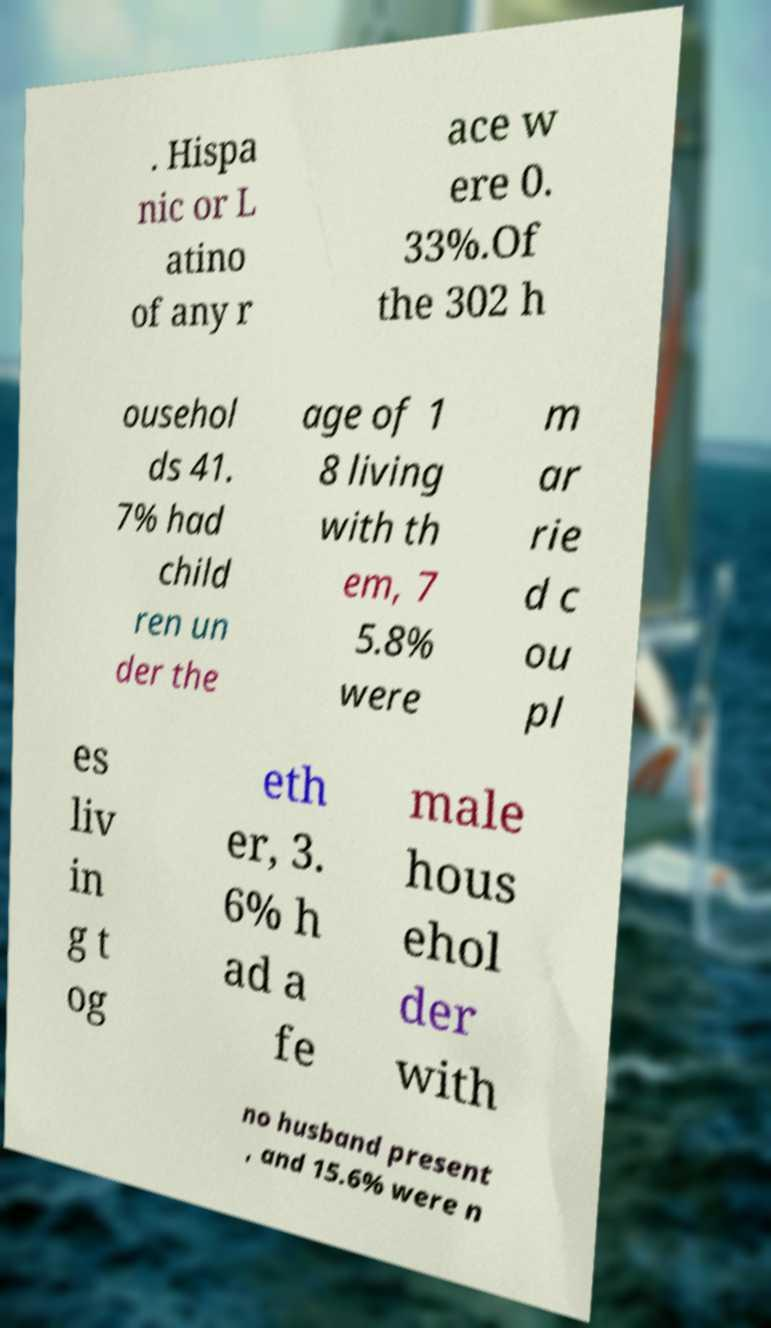Could you assist in decoding the text presented in this image and type it out clearly? . Hispa nic or L atino of any r ace w ere 0. 33%.Of the 302 h ousehol ds 41. 7% had child ren un der the age of 1 8 living with th em, 7 5.8% were m ar rie d c ou pl es liv in g t og eth er, 3. 6% h ad a fe male hous ehol der with no husband present , and 15.6% were n 